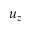<formula> <loc_0><loc_0><loc_500><loc_500>u _ { z }</formula> 